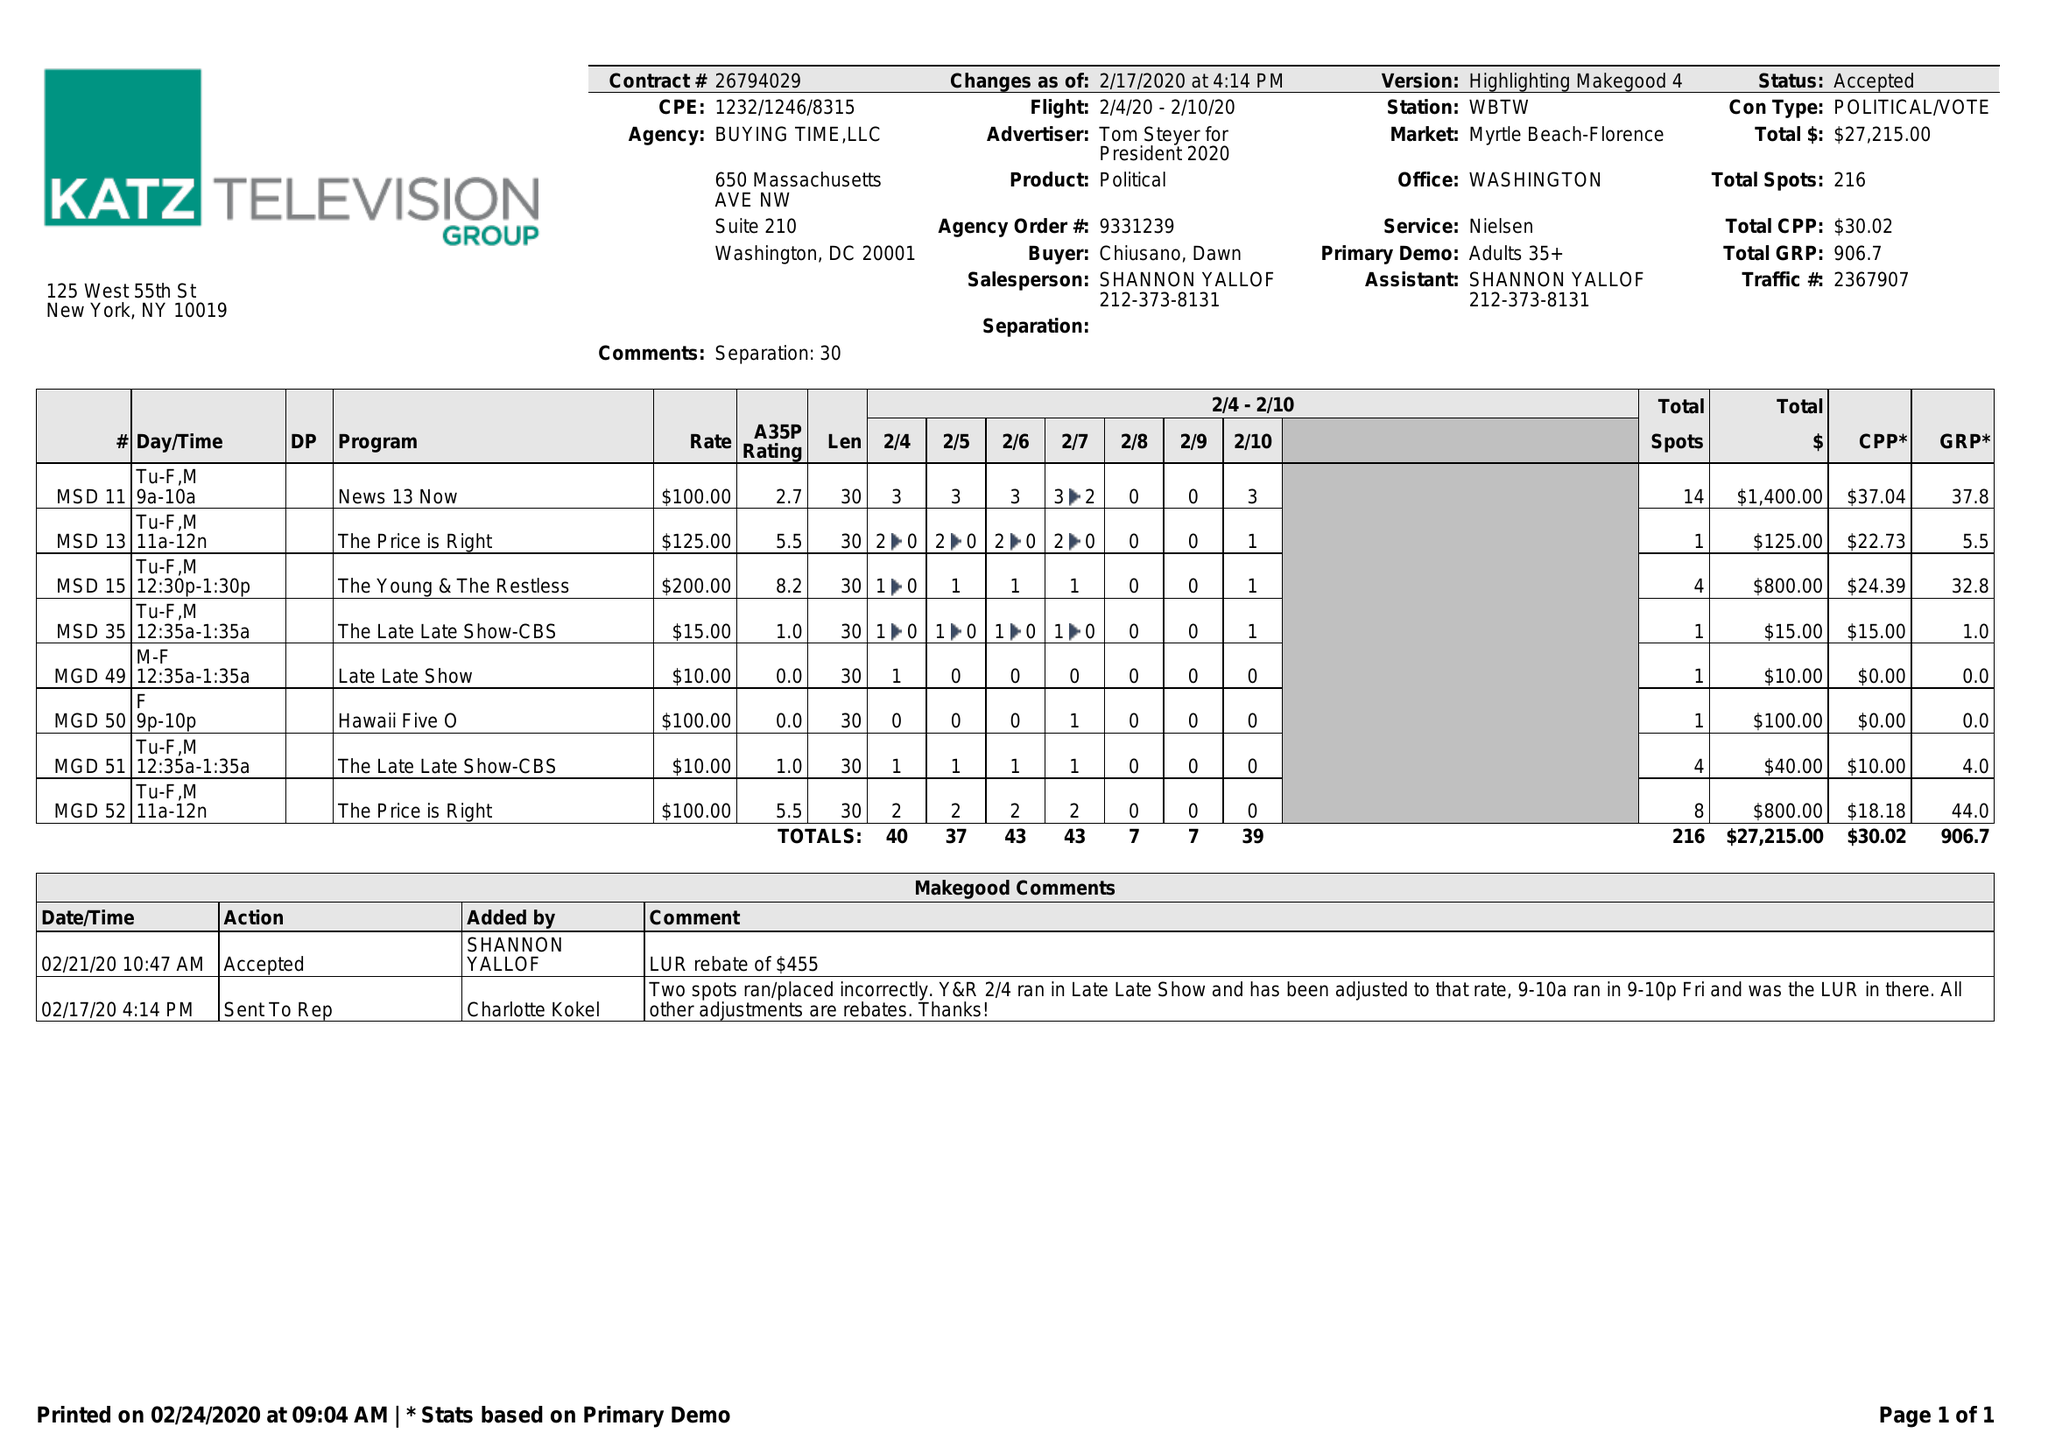What is the value for the gross_amount?
Answer the question using a single word or phrase. 27215.00 